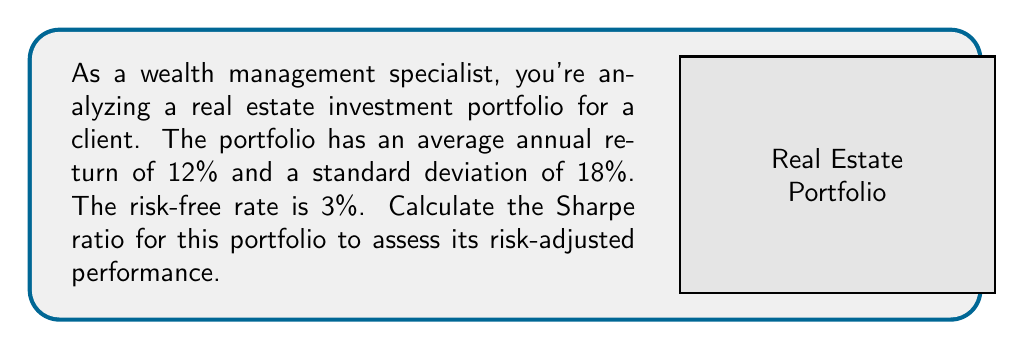Could you help me with this problem? To calculate the Sharpe ratio, we'll follow these steps:

1) The Sharpe ratio formula is:

   $$ S = \frac{R_p - R_f}{\sigma_p} $$

   Where:
   $S$ = Sharpe ratio
   $R_p$ = Portfolio return
   $R_f$ = Risk-free rate
   $\sigma_p$ = Portfolio standard deviation

2) We're given:
   $R_p = 12\%$
   $R_f = 3\%$
   $\sigma_p = 18\%$

3) Let's substitute these values into the formula:

   $$ S = \frac{0.12 - 0.03}{0.18} $$

4) Simplify:
   $$ S = \frac{0.09}{0.18} $$

5) Calculate:
   $$ S = 0.5 $$

The Sharpe ratio of 0.5 indicates the portfolio's excess return per unit of risk. A higher Sharpe ratio suggests better risk-adjusted performance.
Answer: $0.5$ 